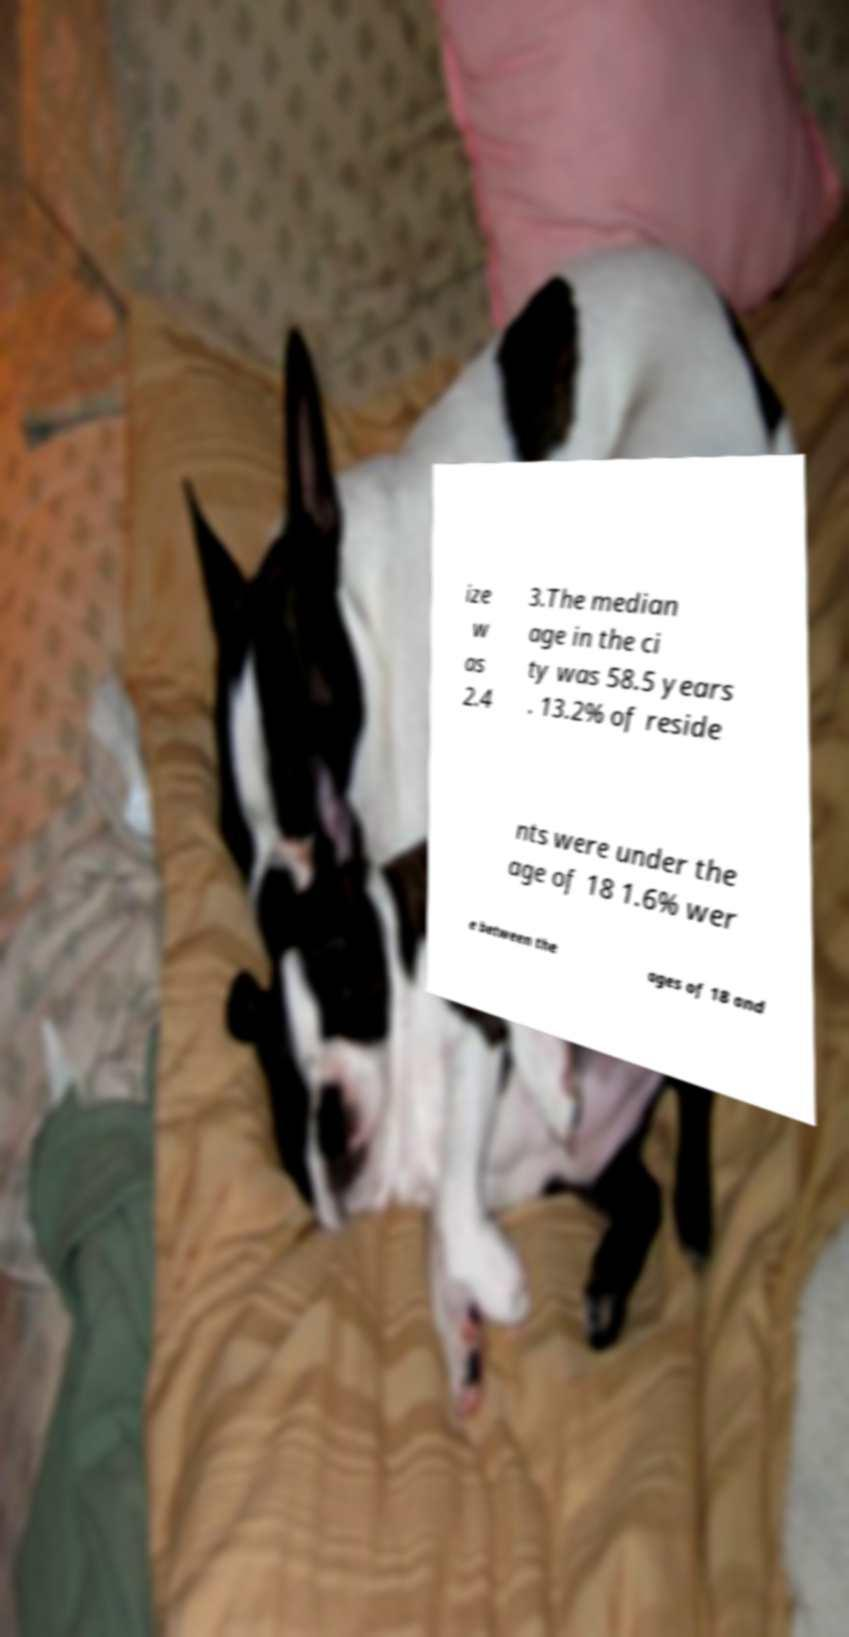Can you accurately transcribe the text from the provided image for me? ize w as 2.4 3.The median age in the ci ty was 58.5 years . 13.2% of reside nts were under the age of 18 1.6% wer e between the ages of 18 and 